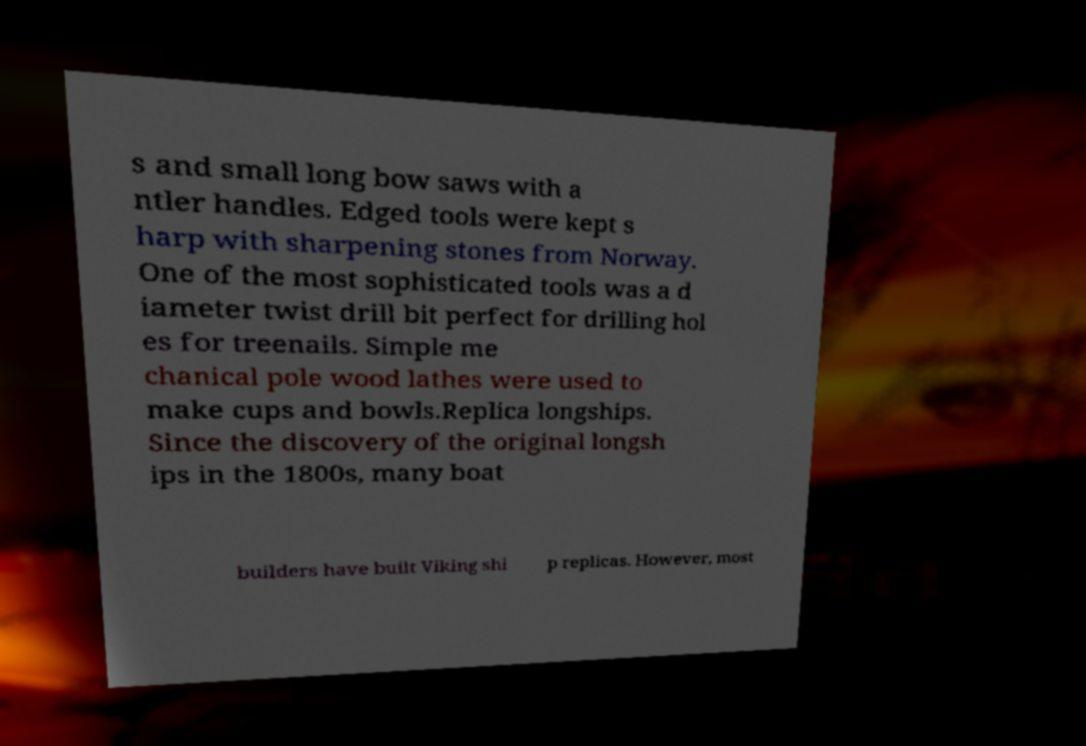Could you assist in decoding the text presented in this image and type it out clearly? s and small long bow saws with a ntler handles. Edged tools were kept s harp with sharpening stones from Norway. One of the most sophisticated tools was a d iameter twist drill bit perfect for drilling hol es for treenails. Simple me chanical pole wood lathes were used to make cups and bowls.Replica longships. Since the discovery of the original longsh ips in the 1800s, many boat builders have built Viking shi p replicas. However, most 